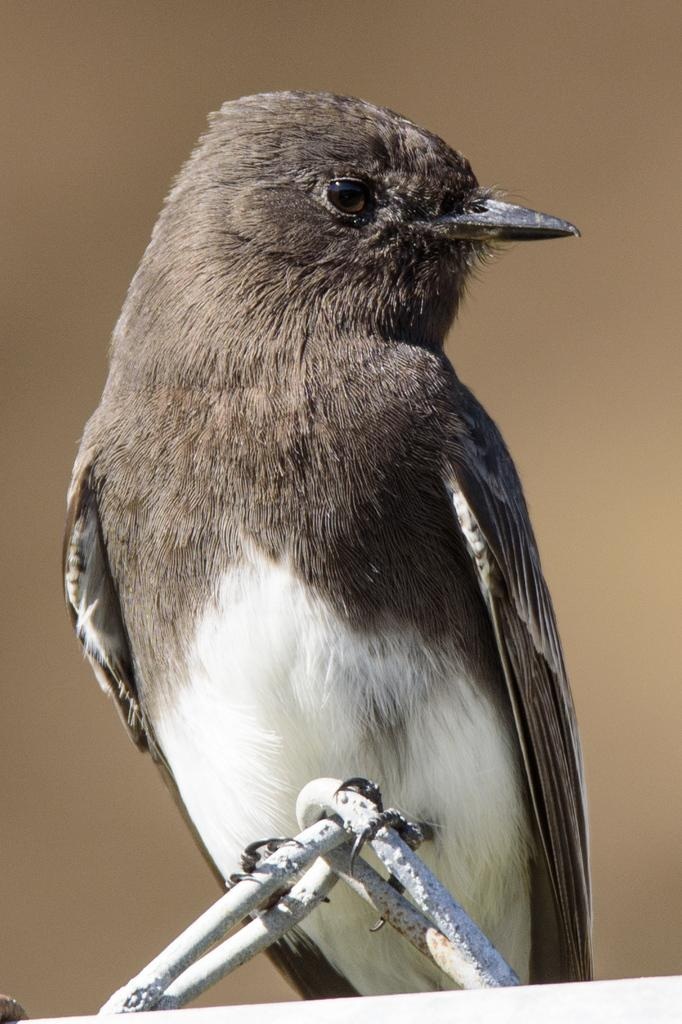What is the main subject of the image? There is a bird in the center of the image. Can you describe the bird's position in the image? The bird is located in the center of the image. What might the bird be doing in the image? It is not clear what the bird is doing in the image, but it is the main focus. What type of magic spell does the bird cast on the bun in the image? There is no bun or magic spell present in the image; it only features a bird in the center. 